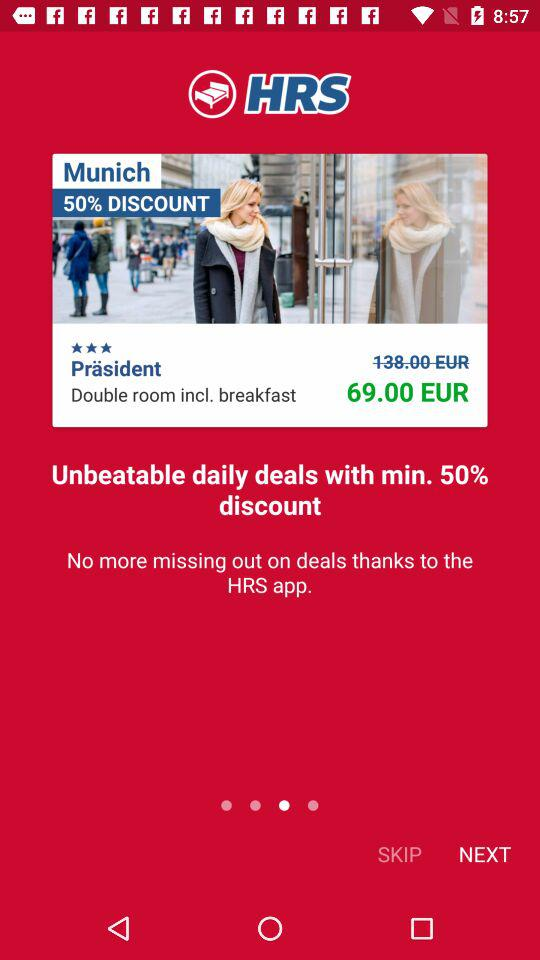How much is the original price of the hotel room?
Answer the question using a single word or phrase. 138.00 EUR 